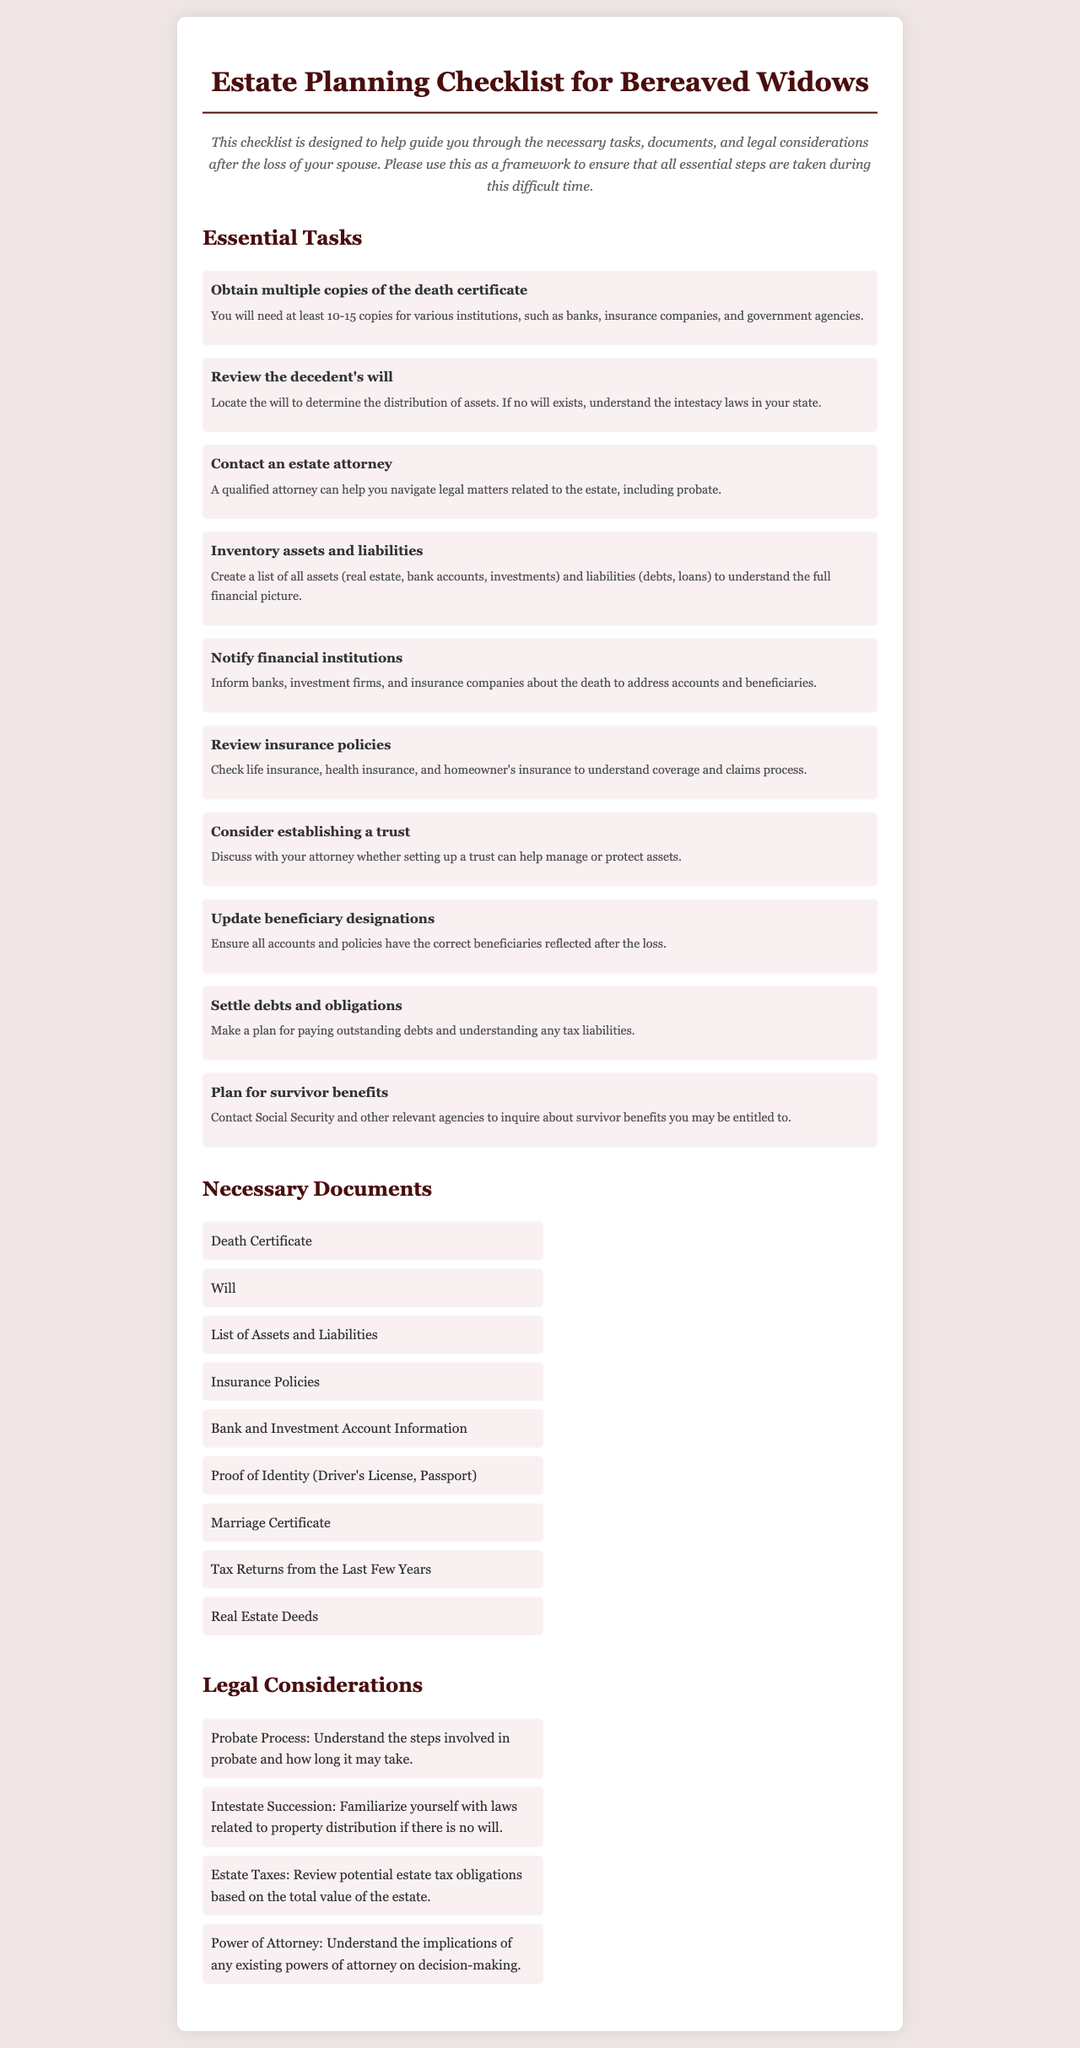What is the first essential task listed? The first essential task is specified in the list of Essential Tasks and is to obtain multiple copies of the death certificate.
Answer: Obtain multiple copies of the death certificate How many copies of the death certificate are suggested? The document suggests obtaining at least 10-15 copies for various purposes.
Answer: 10-15 What document should be reviewed to determine asset distribution? The document indicates that the decedent's will should be reviewed to determine the distribution of assets.
Answer: Will Which certificate is necessary to prove identity? The document mentions that a driver's license or passport serves as proof of identity.
Answer: Driver's License, Passport What legal consideration relates to property distribution if there's no will? The document outlines that understanding intestate succession is important if no will exists.
Answer: Intestate Succession What should be created to understand the financial picture? The checklist advises creating a list of all assets and liabilities to understand the full financial picture.
Answer: List of Assets and Liabilities What type of attorney should be contacted? The document states that a qualified estate attorney should be contacted for legal matters related to the estate.
Answer: Estate Attorney What might you need to settle related to debts? The document outlines the need to settle debts and obligations as a necessary task following a loss.
Answer: Debts and obligations What is necessary to inquire about survivor benefits? The checklist advises contacting Social Security and other relevant agencies regarding survivor benefits.
Answer: Social Security and other agencies 